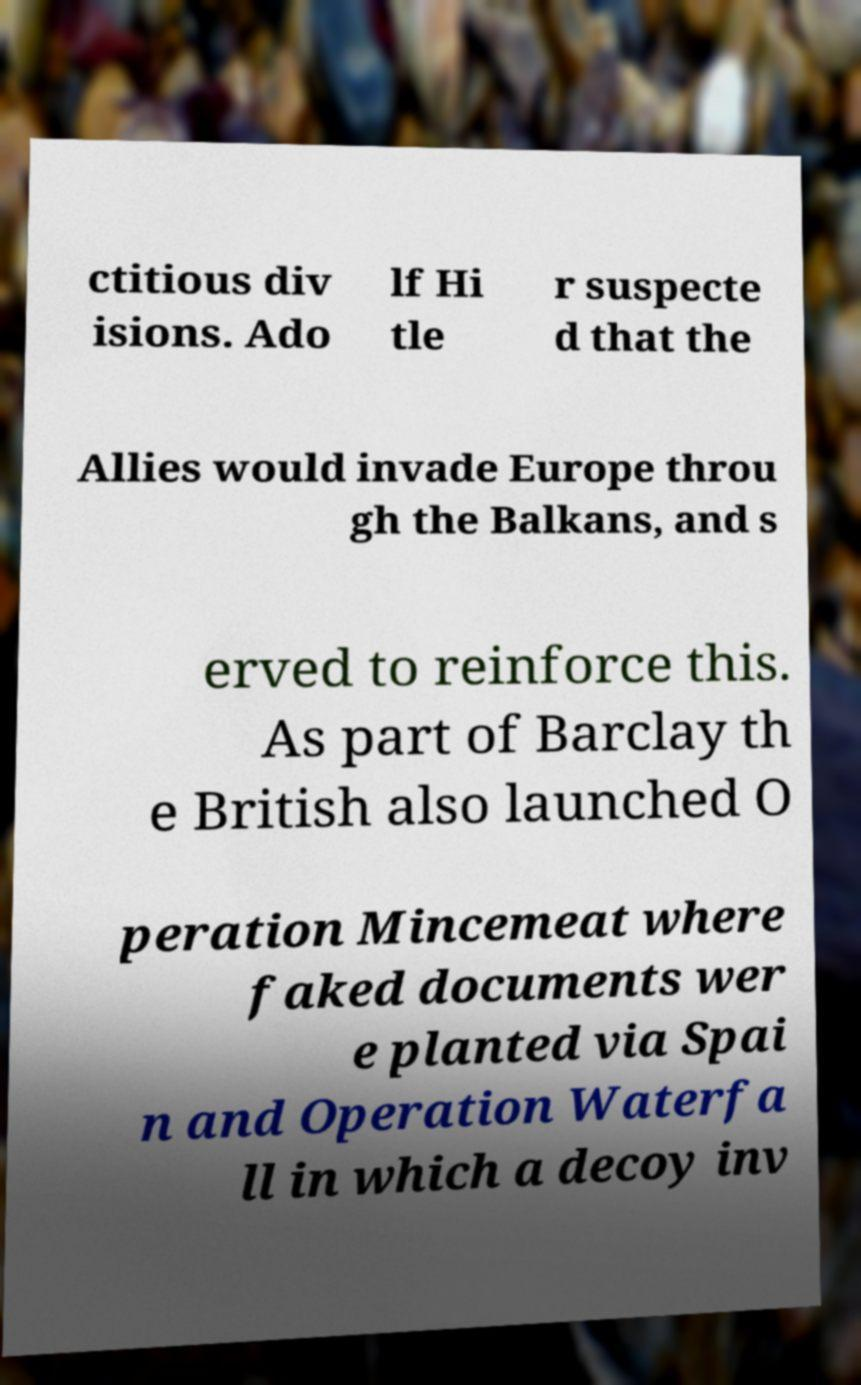Can you accurately transcribe the text from the provided image for me? ctitious div isions. Ado lf Hi tle r suspecte d that the Allies would invade Europe throu gh the Balkans, and s erved to reinforce this. As part of Barclay th e British also launched O peration Mincemeat where faked documents wer e planted via Spai n and Operation Waterfa ll in which a decoy inv 